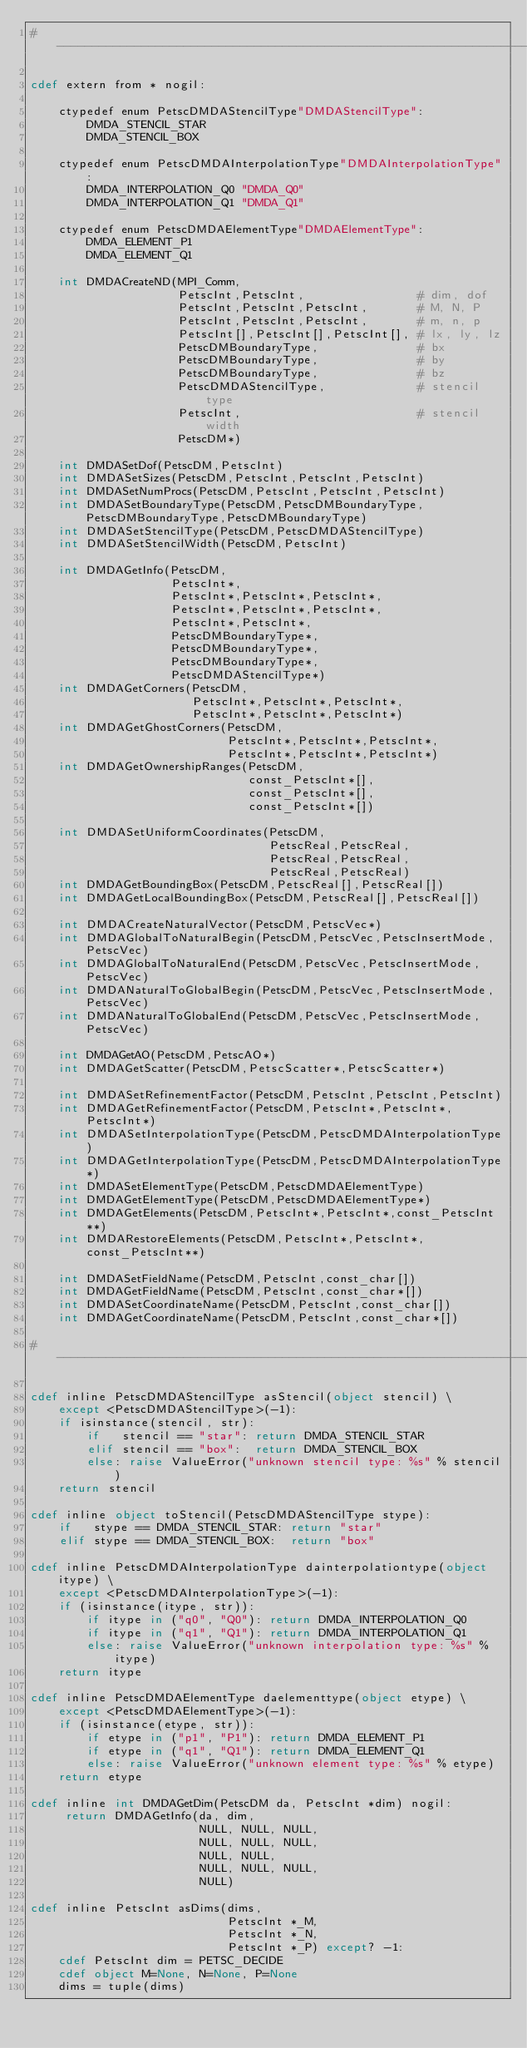<code> <loc_0><loc_0><loc_500><loc_500><_Cython_># --------------------------------------------------------------------

cdef extern from * nogil:

    ctypedef enum PetscDMDAStencilType"DMDAStencilType":
        DMDA_STENCIL_STAR
        DMDA_STENCIL_BOX

    ctypedef enum PetscDMDAInterpolationType"DMDAInterpolationType":
        DMDA_INTERPOLATION_Q0 "DMDA_Q0"
        DMDA_INTERPOLATION_Q1 "DMDA_Q1"

    ctypedef enum PetscDMDAElementType"DMDAElementType":
        DMDA_ELEMENT_P1
        DMDA_ELEMENT_Q1

    int DMDACreateND(MPI_Comm,
                     PetscInt,PetscInt,                # dim, dof
                     PetscInt,PetscInt,PetscInt,       # M, N, P
                     PetscInt,PetscInt,PetscInt,       # m, n, p
                     PetscInt[],PetscInt[],PetscInt[], # lx, ly, lz
                     PetscDMBoundaryType,              # bx
                     PetscDMBoundaryType,              # by
                     PetscDMBoundaryType,              # bz
                     PetscDMDAStencilType,             # stencil type
                     PetscInt,                         # stencil width
                     PetscDM*)
    
    int DMDASetDof(PetscDM,PetscInt)
    int DMDASetSizes(PetscDM,PetscInt,PetscInt,PetscInt)
    int DMDASetNumProcs(PetscDM,PetscInt,PetscInt,PetscInt)
    int DMDASetBoundaryType(PetscDM,PetscDMBoundaryType,PetscDMBoundaryType,PetscDMBoundaryType)
    int DMDASetStencilType(PetscDM,PetscDMDAStencilType)
    int DMDASetStencilWidth(PetscDM,PetscInt)

    int DMDAGetInfo(PetscDM,
                    PetscInt*,
                    PetscInt*,PetscInt*,PetscInt*,
                    PetscInt*,PetscInt*,PetscInt*,
                    PetscInt*,PetscInt*,
                    PetscDMBoundaryType*,
                    PetscDMBoundaryType*,
                    PetscDMBoundaryType*,
                    PetscDMDAStencilType*)
    int DMDAGetCorners(PetscDM,
                       PetscInt*,PetscInt*,PetscInt*,
                       PetscInt*,PetscInt*,PetscInt*)
    int DMDAGetGhostCorners(PetscDM,
                            PetscInt*,PetscInt*,PetscInt*,
                            PetscInt*,PetscInt*,PetscInt*)
    int DMDAGetOwnershipRanges(PetscDM,
                               const_PetscInt*[],
                               const_PetscInt*[],
                               const_PetscInt*[])

    int DMDASetUniformCoordinates(PetscDM,
                                  PetscReal,PetscReal,
                                  PetscReal,PetscReal,
                                  PetscReal,PetscReal)
    int DMDAGetBoundingBox(PetscDM,PetscReal[],PetscReal[])
    int DMDAGetLocalBoundingBox(PetscDM,PetscReal[],PetscReal[])

    int DMDACreateNaturalVector(PetscDM,PetscVec*)
    int DMDAGlobalToNaturalBegin(PetscDM,PetscVec,PetscInsertMode,PetscVec)
    int DMDAGlobalToNaturalEnd(PetscDM,PetscVec,PetscInsertMode,PetscVec)
    int DMDANaturalToGlobalBegin(PetscDM,PetscVec,PetscInsertMode,PetscVec)
    int DMDANaturalToGlobalEnd(PetscDM,PetscVec,PetscInsertMode,PetscVec)

    int DMDAGetAO(PetscDM,PetscAO*)
    int DMDAGetScatter(PetscDM,PetscScatter*,PetscScatter*)

    int DMDASetRefinementFactor(PetscDM,PetscInt,PetscInt,PetscInt)
    int DMDAGetRefinementFactor(PetscDM,PetscInt*,PetscInt*,PetscInt*)
    int DMDASetInterpolationType(PetscDM,PetscDMDAInterpolationType)
    int DMDAGetInterpolationType(PetscDM,PetscDMDAInterpolationType*)
    int DMDASetElementType(PetscDM,PetscDMDAElementType)
    int DMDAGetElementType(PetscDM,PetscDMDAElementType*)
    int DMDAGetElements(PetscDM,PetscInt*,PetscInt*,const_PetscInt**)
    int DMDARestoreElements(PetscDM,PetscInt*,PetscInt*,const_PetscInt**)

    int DMDASetFieldName(PetscDM,PetscInt,const_char[])
    int DMDAGetFieldName(PetscDM,PetscInt,const_char*[])
    int DMDASetCoordinateName(PetscDM,PetscInt,const_char[])
    int DMDAGetCoordinateName(PetscDM,PetscInt,const_char*[])

# --------------------------------------------------------------------

cdef inline PetscDMDAStencilType asStencil(object stencil) \
    except <PetscDMDAStencilType>(-1):
    if isinstance(stencil, str):
        if   stencil == "star": return DMDA_STENCIL_STAR
        elif stencil == "box":  return DMDA_STENCIL_BOX
        else: raise ValueError("unknown stencil type: %s" % stencil)
    return stencil

cdef inline object toStencil(PetscDMDAStencilType stype):
    if   stype == DMDA_STENCIL_STAR: return "star"
    elif stype == DMDA_STENCIL_BOX:  return "box"

cdef inline PetscDMDAInterpolationType dainterpolationtype(object itype) \
    except <PetscDMDAInterpolationType>(-1):
    if (isinstance(itype, str)):
        if itype in ("q0", "Q0"): return DMDA_INTERPOLATION_Q0
        if itype in ("q1", "Q1"): return DMDA_INTERPOLATION_Q1
        else: raise ValueError("unknown interpolation type: %s" % itype)
    return itype

cdef inline PetscDMDAElementType daelementtype(object etype) \
    except <PetscDMDAElementType>(-1):
    if (isinstance(etype, str)):
        if etype in ("p1", "P1"): return DMDA_ELEMENT_P1
        if etype in ("q1", "Q1"): return DMDA_ELEMENT_Q1
        else: raise ValueError("unknown element type: %s" % etype)
    return etype

cdef inline int DMDAGetDim(PetscDM da, PetscInt *dim) nogil:
     return DMDAGetInfo(da, dim,
                        NULL, NULL, NULL,
                        NULL, NULL, NULL,
                        NULL, NULL,
                        NULL, NULL, NULL,
                        NULL)

cdef inline PetscInt asDims(dims,
                            PetscInt *_M,
                            PetscInt *_N,
                            PetscInt *_P) except? -1:
    cdef PetscInt dim = PETSC_DECIDE
    cdef object M=None, N=None, P=None
    dims = tuple(dims)</code> 